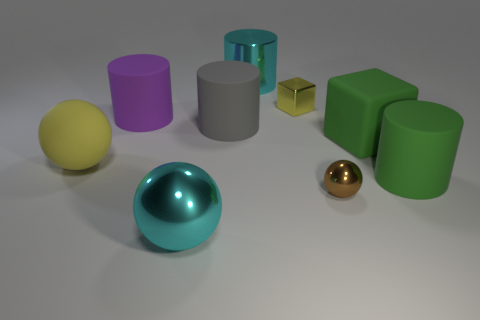Which object in the image looks most reflective? The sphere in the front, with a teal hue, appears to be the most reflective object, likely due to its polished surface which catches the light and shows discernible highlights. 